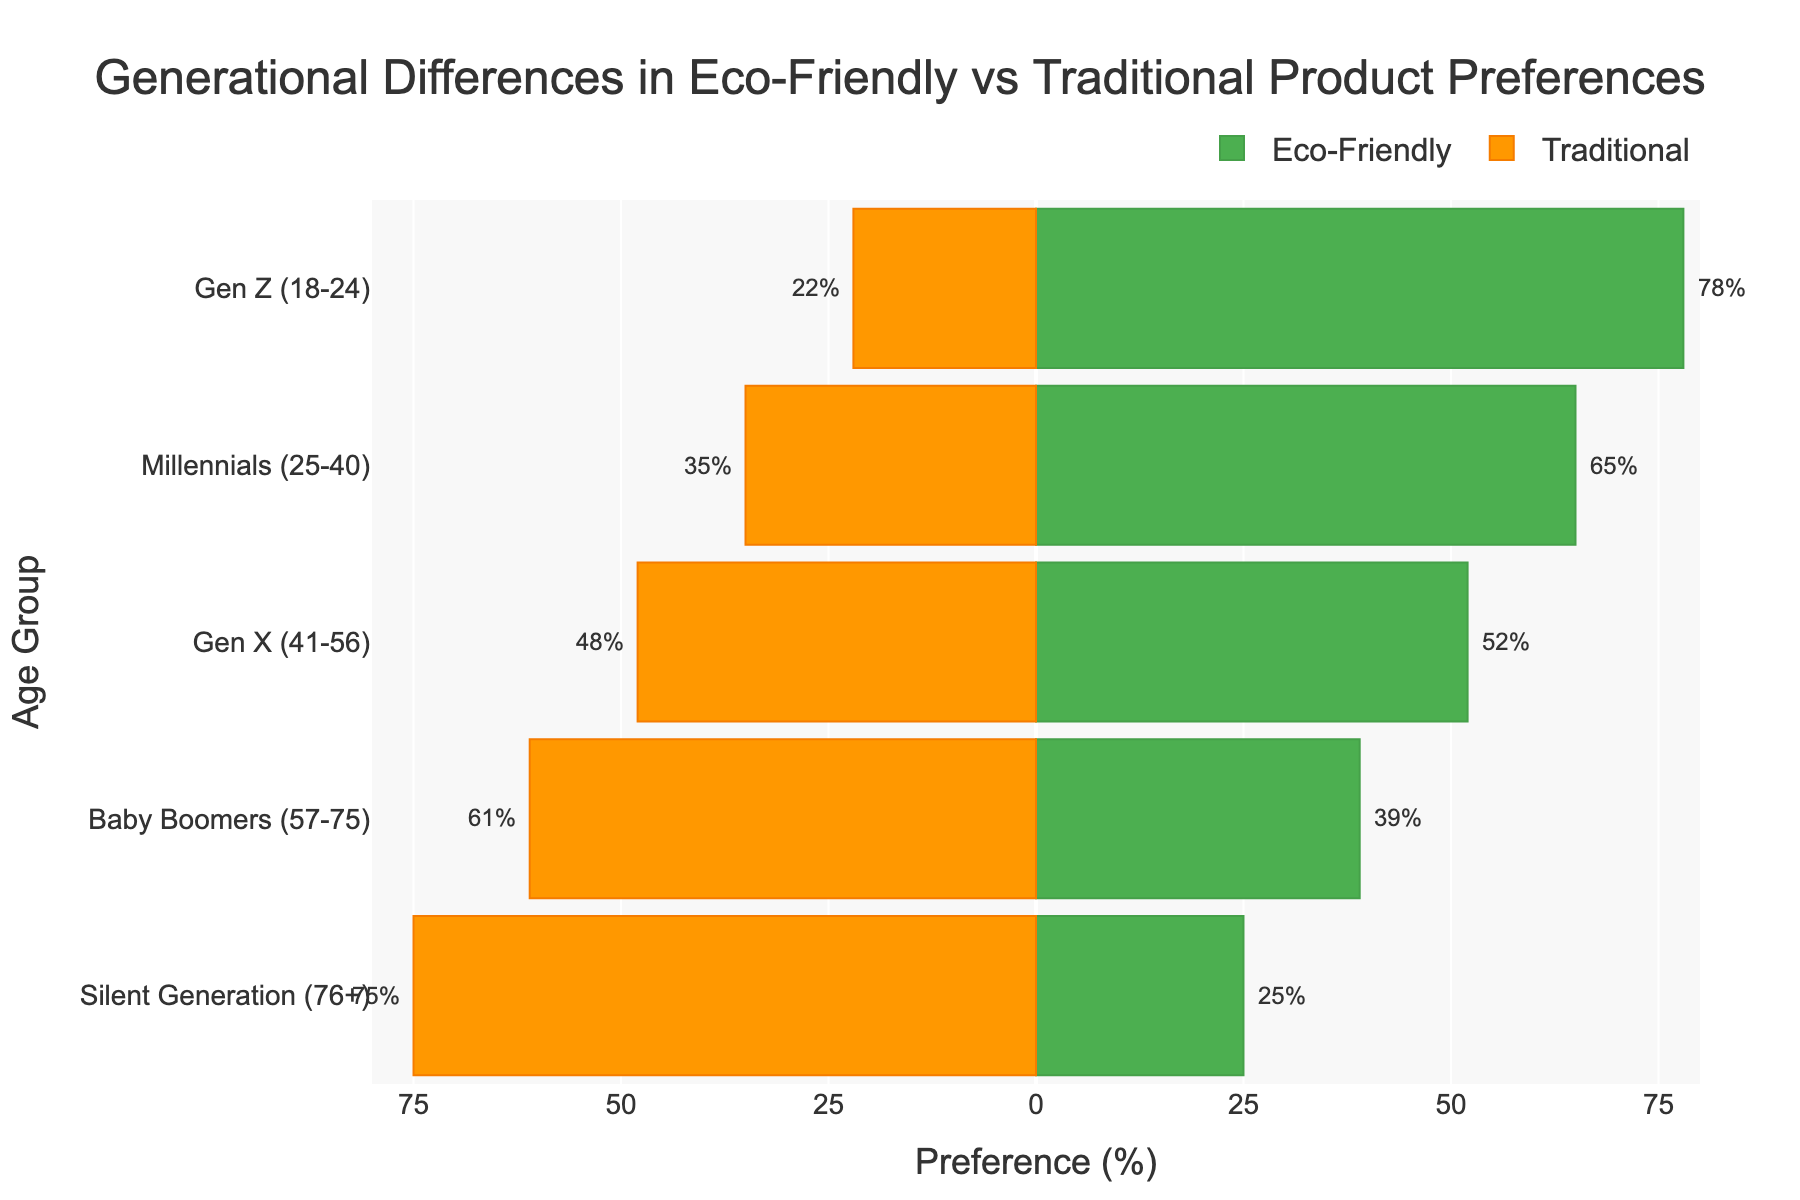What is the title of the chart? The title of the chart is located at the top of the figure. It usually provides a concise description of the chart's subject matter. By reading it, we can determine the overall theme of the chart.
Answer: Generational Differences in Eco-Friendly vs Traditional Product Preferences Which generation has the highest adoption rate of eco-friendly products? To find the generation with the highest adoption rate of eco-friendly products, look at the bar that extends farthest to the right on the positive percentage side.
Answer: Gen Z What percentage of Baby Boomers prefer traditional products? Identify the Baby Boomers age group and look at the length of the orange bar extending to the left for traditional product preference. It's also marked with a text annotation.
Answer: 61% How does the eco-friendly product adoption rate of Millennials compare to that of Gen X? Compare the lengths of the green bars for Millennials and Gen X to see which extends further to the right on the positive percentage side.
Answer: Millennials have a higher rate than Gen X What's the difference in traditional product preference between Silent Generation and Gen Z? Look at the lengths of the orange bars extending to the left for both Silent Generation and Gen Z, noting the specific percentages. Subtract the percentage of Gen Z from the percentage of Silent Generation.
Answer: 75% - 22% = 53% Calculate the average eco-friendly product adoption rate across all generations. Sum the eco-friendly adoption percentages for each generation and then divide by the number of generations (5 in this case). (78 + 65 + 52 + 39 + 25) / 5
Answer: 51.8% How does the preference for traditional products change from Gen Z to the Silent Generation? Observe the trend in the orange bars from Gen Z to the Silent Generation, noting whether the bars become longer (increase in traditional preference) or shorter (decrease in traditional preference).
Answer: It increases Which generation has the closest split between eco-friendly and traditional product preferences? Look for the generation where the lengths of the green and orange bars are most similar or closest in value.
Answer: Gen X What is the range in eco-friendly product adoption rates among the generations? Identify the highest and lowest eco-friendly product adoption rates and subtract the lowest from the highest. (78% for Gen Z) - (25% for Silent Generation)
Answer: 53% 